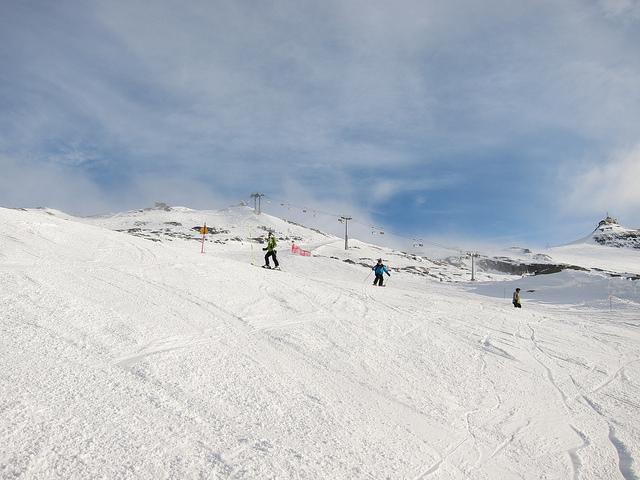How many elephants are under a tree branch?
Give a very brief answer. 0. 